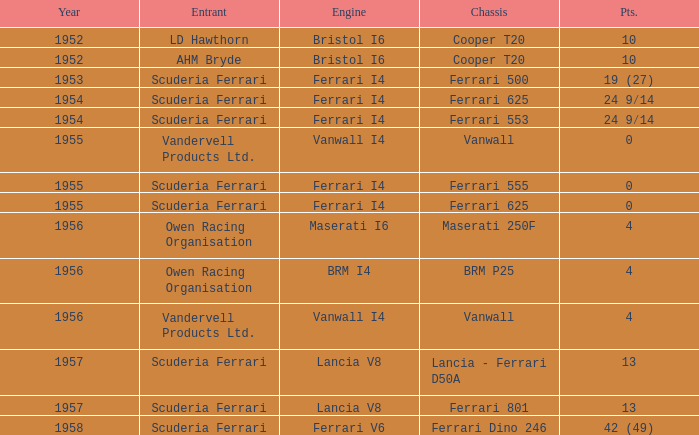Which entrant has 4 points and BRM p25 for the Chassis? Owen Racing Organisation. 